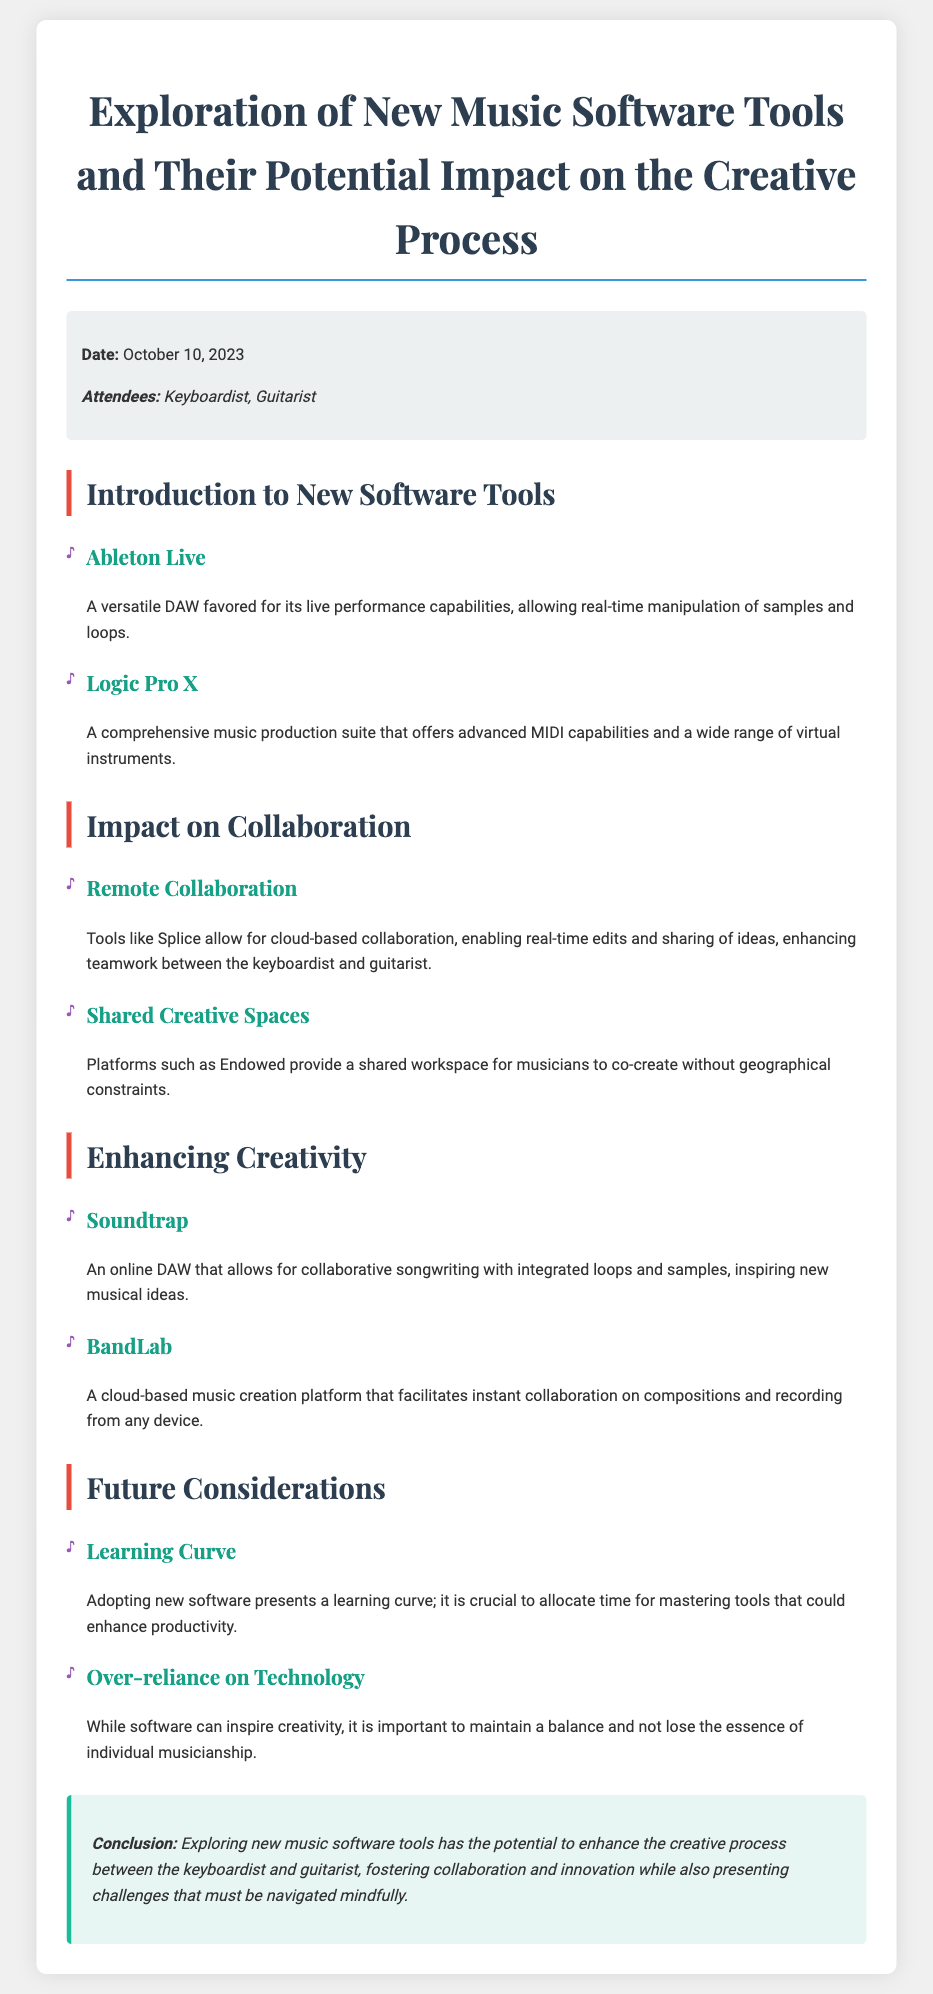What is the date of the meeting? The date of the meeting is stated in the meta-info section of the document as October 10, 2023.
Answer: October 10, 2023 Who are the attendees mentioned in the document? The attendees are listed in the meta-info section, specifically the keyboardist and guitarist.
Answer: Keyboardist, Guitarist What is the first software tool introduced? The first software tool is mentioned under the introduction section, identified as Ableton Live.
Answer: Ableton Live Which platform facilitates instant collaboration on compositions? The platform facilitating instant collaboration is referred to in the enhancing creativity section, specifically BandLab.
Answer: BandLab What is one potential challenge of adopting new software? A challenge mentioned in the future considerations section is the learning curve associated with new software.
Answer: Learning Curve How does Splice enhance teamwork? Splice enhances teamwork by allowing for cloud-based collaboration and real-time edits, as stated in the impact on collaboration section.
Answer: Cloud-based collaboration What is the main conclusion of the document? The conclusion summarizes the potential enhancement of the creative process through new software tools while considering challenges, as outlined in the conclusion section.
Answer: Enhance the creative process What is one of the potential downsides of using music software? One downside mentioned in the future considerations section is the over-reliance on technology.
Answer: Over-reliance on Technology 